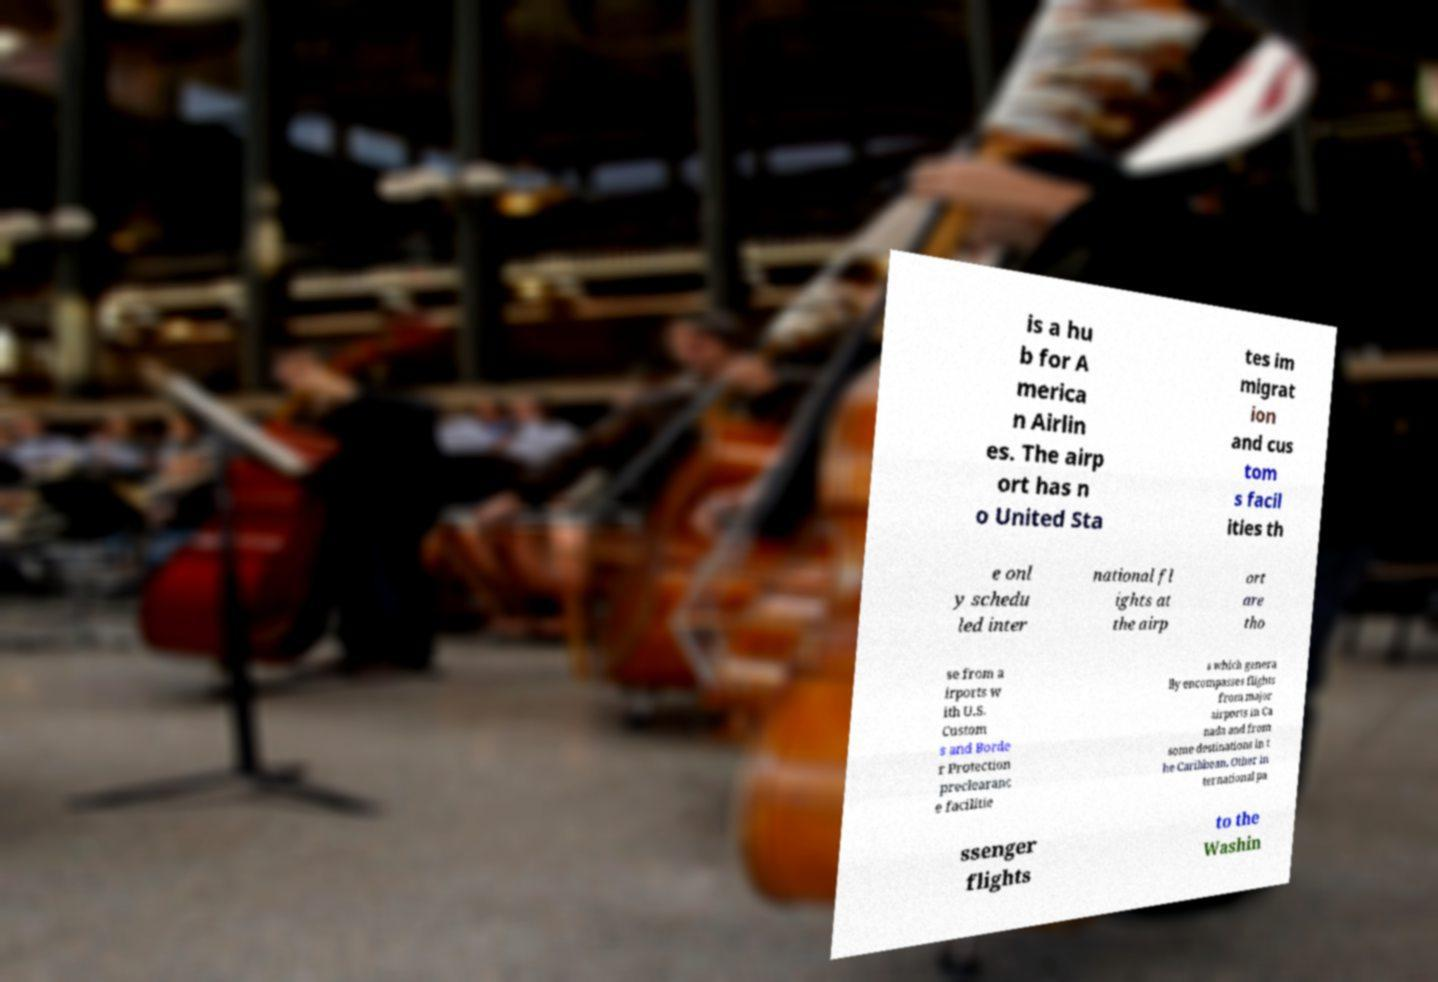Please read and relay the text visible in this image. What does it say? is a hu b for A merica n Airlin es. The airp ort has n o United Sta tes im migrat ion and cus tom s facil ities th e onl y schedu led inter national fl ights at the airp ort are tho se from a irports w ith U.S. Custom s and Borde r Protection preclearanc e facilitie s which genera lly encompasses flights from major airports in Ca nada and from some destinations in t he Caribbean. Other in ternational pa ssenger flights to the Washin 